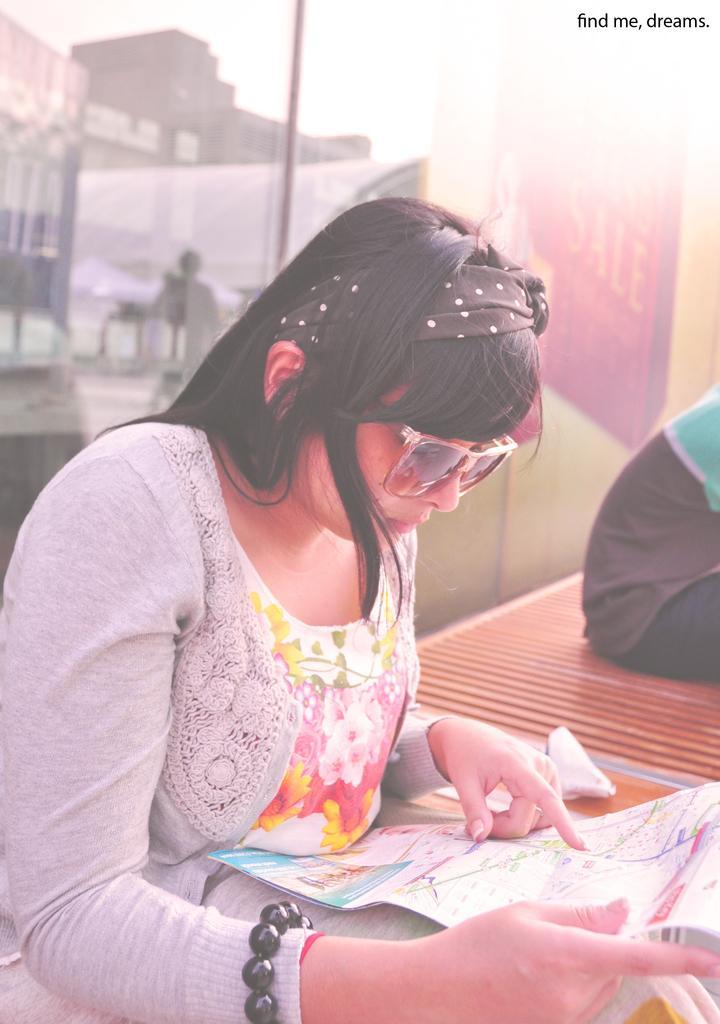Can you describe this image briefly? In this image there is a lady sitting on a chair seeing a paper, beside the lady there is a table on that table there is a person sitting, in the background it is blurred, in the top right there is text. 